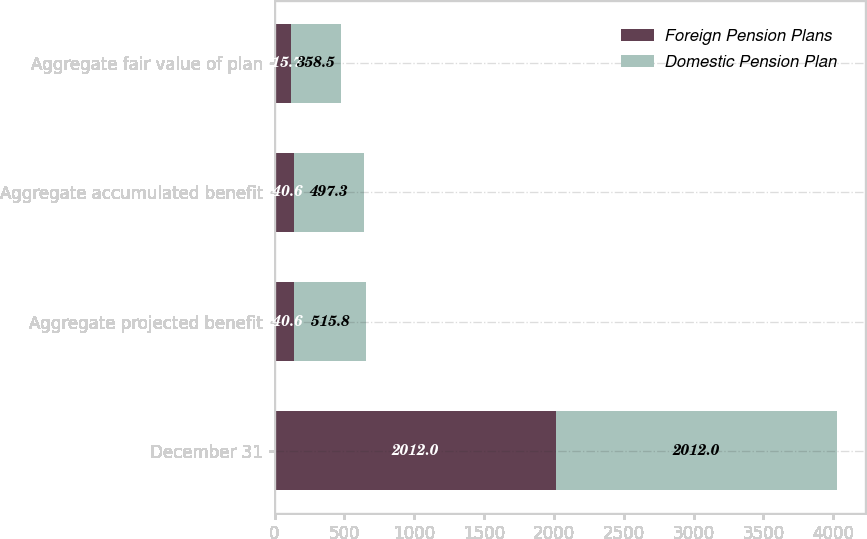Convert chart. <chart><loc_0><loc_0><loc_500><loc_500><stacked_bar_chart><ecel><fcel>December 31<fcel>Aggregate projected benefit<fcel>Aggregate accumulated benefit<fcel>Aggregate fair value of plan<nl><fcel>Foreign Pension Plans<fcel>2012<fcel>140.6<fcel>140.6<fcel>115.7<nl><fcel>Domestic Pension Plan<fcel>2012<fcel>515.8<fcel>497.3<fcel>358.5<nl></chart> 